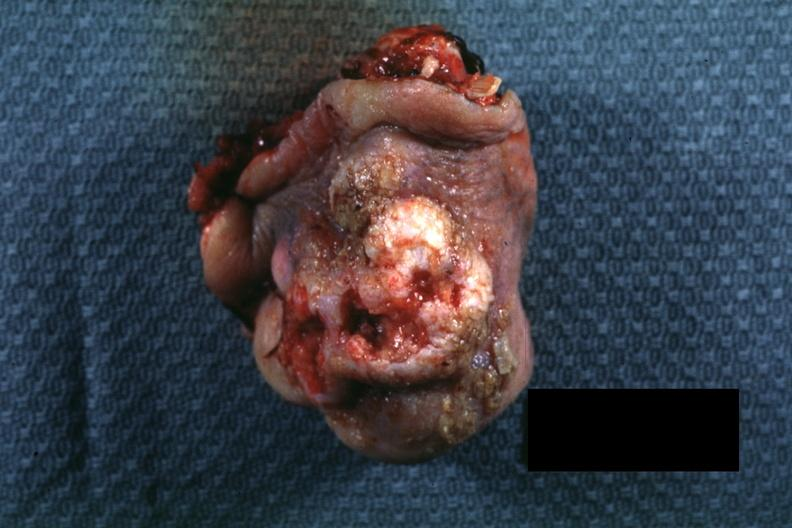s squamous cell carcinoma present?
Answer the question using a single word or phrase. Yes 